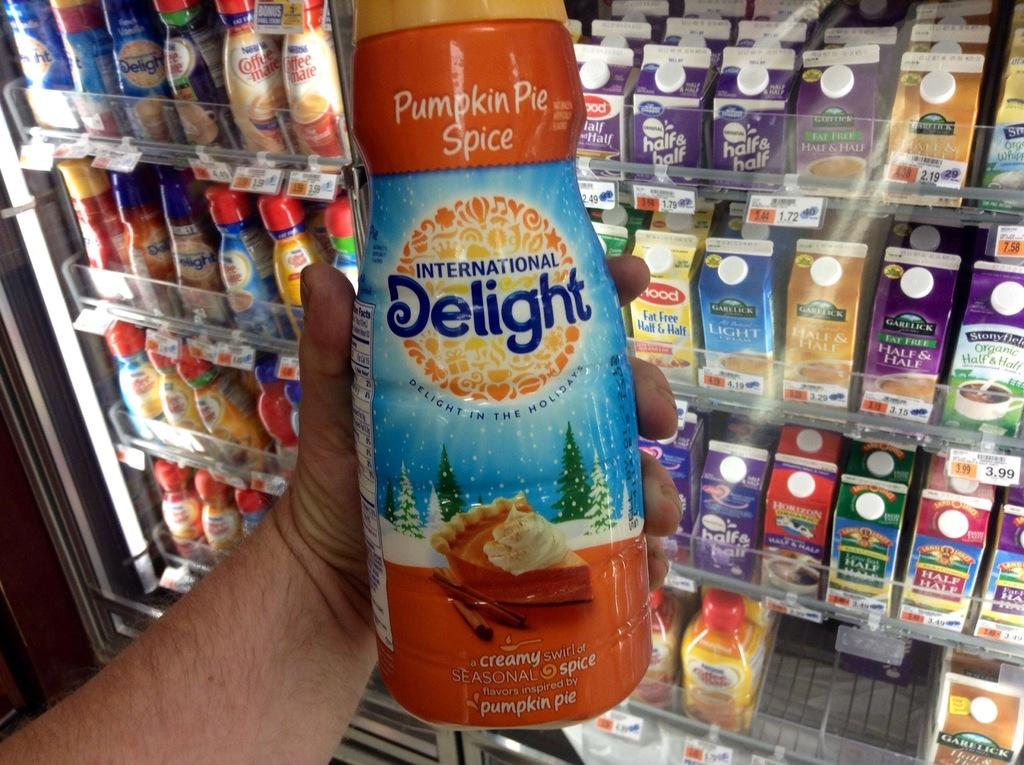What is there is a person holding a bottle in the image, what is the person doing with the bottle? The person is holding a bottle in the image, but the specific action they are performing with the bottle is not mentioned in the facts. Besides the person holding a bottle, what other bottles can be seen in the image? There are colorful bottles visible in the image. What type of objects can be found on the racks in the image? The facts mention that there are objects on the racks in the image, but the specific objects are not described. What type of orange can be seen growing on the land in the image? There is no orange or land present in the image; it features a person holding a bottle and colorful bottles on racks. 